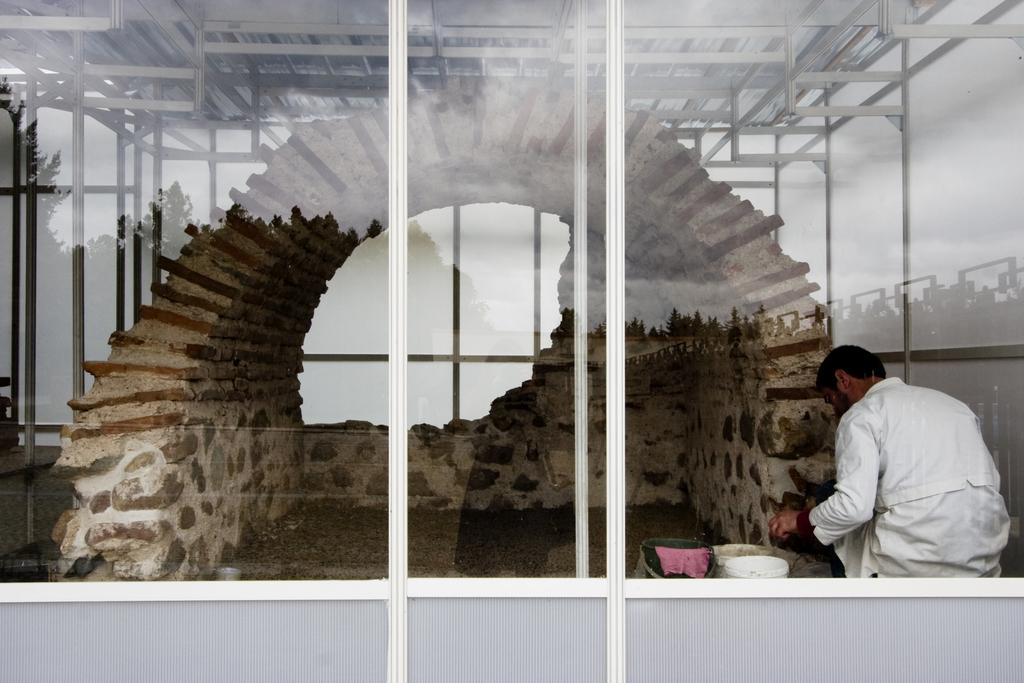What type of door is visible in the image? There is a glass door in the image. Who or what can be seen through the glass door? A man is visible inside the glass door. What is the man doing in the image? The man is cementing a wall. What can be seen at the top of the image? There are iron rods at the top of the image. What is the title of the book the man is reading while cementing the wall? The man is not reading a book in the image; he is cementing a wall. Can you see the moon in the image? The moon is not visible in the image; it is focused on the glass door, the man, and the iron rods. 